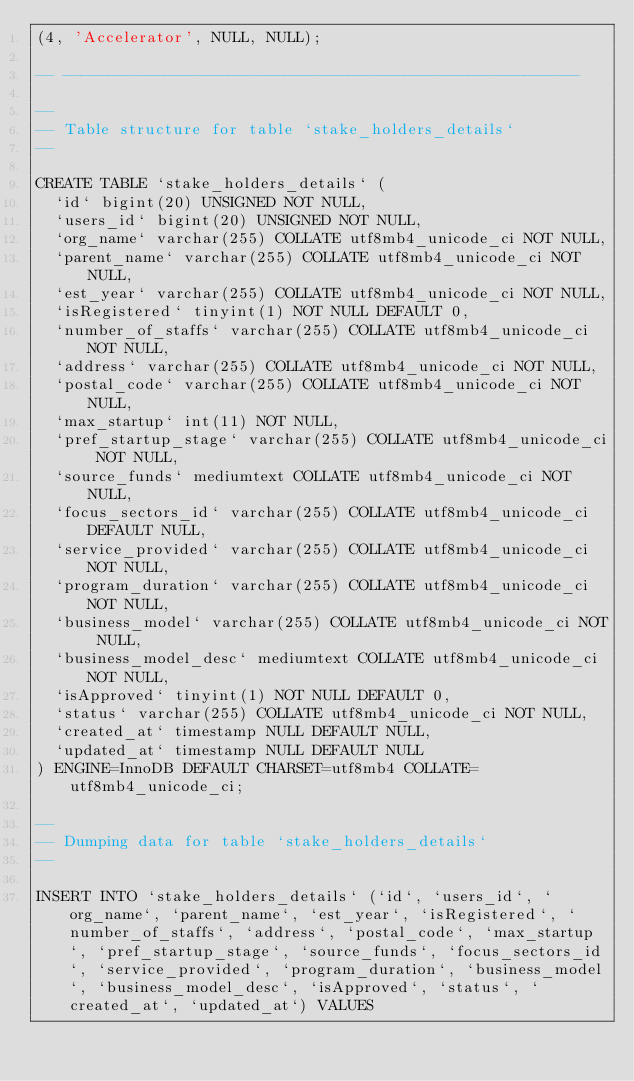<code> <loc_0><loc_0><loc_500><loc_500><_SQL_>(4, 'Accelerator', NULL, NULL);

-- --------------------------------------------------------

--
-- Table structure for table `stake_holders_details`
--

CREATE TABLE `stake_holders_details` (
  `id` bigint(20) UNSIGNED NOT NULL,
  `users_id` bigint(20) UNSIGNED NOT NULL,
  `org_name` varchar(255) COLLATE utf8mb4_unicode_ci NOT NULL,
  `parent_name` varchar(255) COLLATE utf8mb4_unicode_ci NOT NULL,
  `est_year` varchar(255) COLLATE utf8mb4_unicode_ci NOT NULL,
  `isRegistered` tinyint(1) NOT NULL DEFAULT 0,
  `number_of_staffs` varchar(255) COLLATE utf8mb4_unicode_ci NOT NULL,
  `address` varchar(255) COLLATE utf8mb4_unicode_ci NOT NULL,
  `postal_code` varchar(255) COLLATE utf8mb4_unicode_ci NOT NULL,
  `max_startup` int(11) NOT NULL,
  `pref_startup_stage` varchar(255) COLLATE utf8mb4_unicode_ci NOT NULL,
  `source_funds` mediumtext COLLATE utf8mb4_unicode_ci NOT NULL,
  `focus_sectors_id` varchar(255) COLLATE utf8mb4_unicode_ci DEFAULT NULL,
  `service_provided` varchar(255) COLLATE utf8mb4_unicode_ci NOT NULL,
  `program_duration` varchar(255) COLLATE utf8mb4_unicode_ci NOT NULL,
  `business_model` varchar(255) COLLATE utf8mb4_unicode_ci NOT NULL,
  `business_model_desc` mediumtext COLLATE utf8mb4_unicode_ci NOT NULL,
  `isApproved` tinyint(1) NOT NULL DEFAULT 0,
  `status` varchar(255) COLLATE utf8mb4_unicode_ci NOT NULL,
  `created_at` timestamp NULL DEFAULT NULL,
  `updated_at` timestamp NULL DEFAULT NULL
) ENGINE=InnoDB DEFAULT CHARSET=utf8mb4 COLLATE=utf8mb4_unicode_ci;

--
-- Dumping data for table `stake_holders_details`
--

INSERT INTO `stake_holders_details` (`id`, `users_id`, `org_name`, `parent_name`, `est_year`, `isRegistered`, `number_of_staffs`, `address`, `postal_code`, `max_startup`, `pref_startup_stage`, `source_funds`, `focus_sectors_id`, `service_provided`, `program_duration`, `business_model`, `business_model_desc`, `isApproved`, `status`, `created_at`, `updated_at`) VALUES</code> 